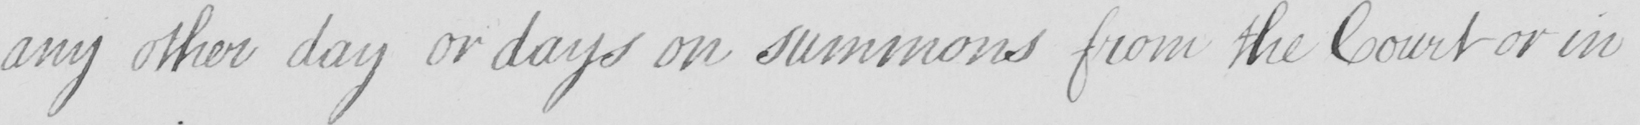Please transcribe the handwritten text in this image. any other day or days on summons from the Court or in 